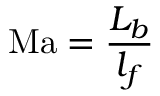<formula> <loc_0><loc_0><loc_500><loc_500>M a = { \frac { L _ { b } } { l _ { f } } }</formula> 